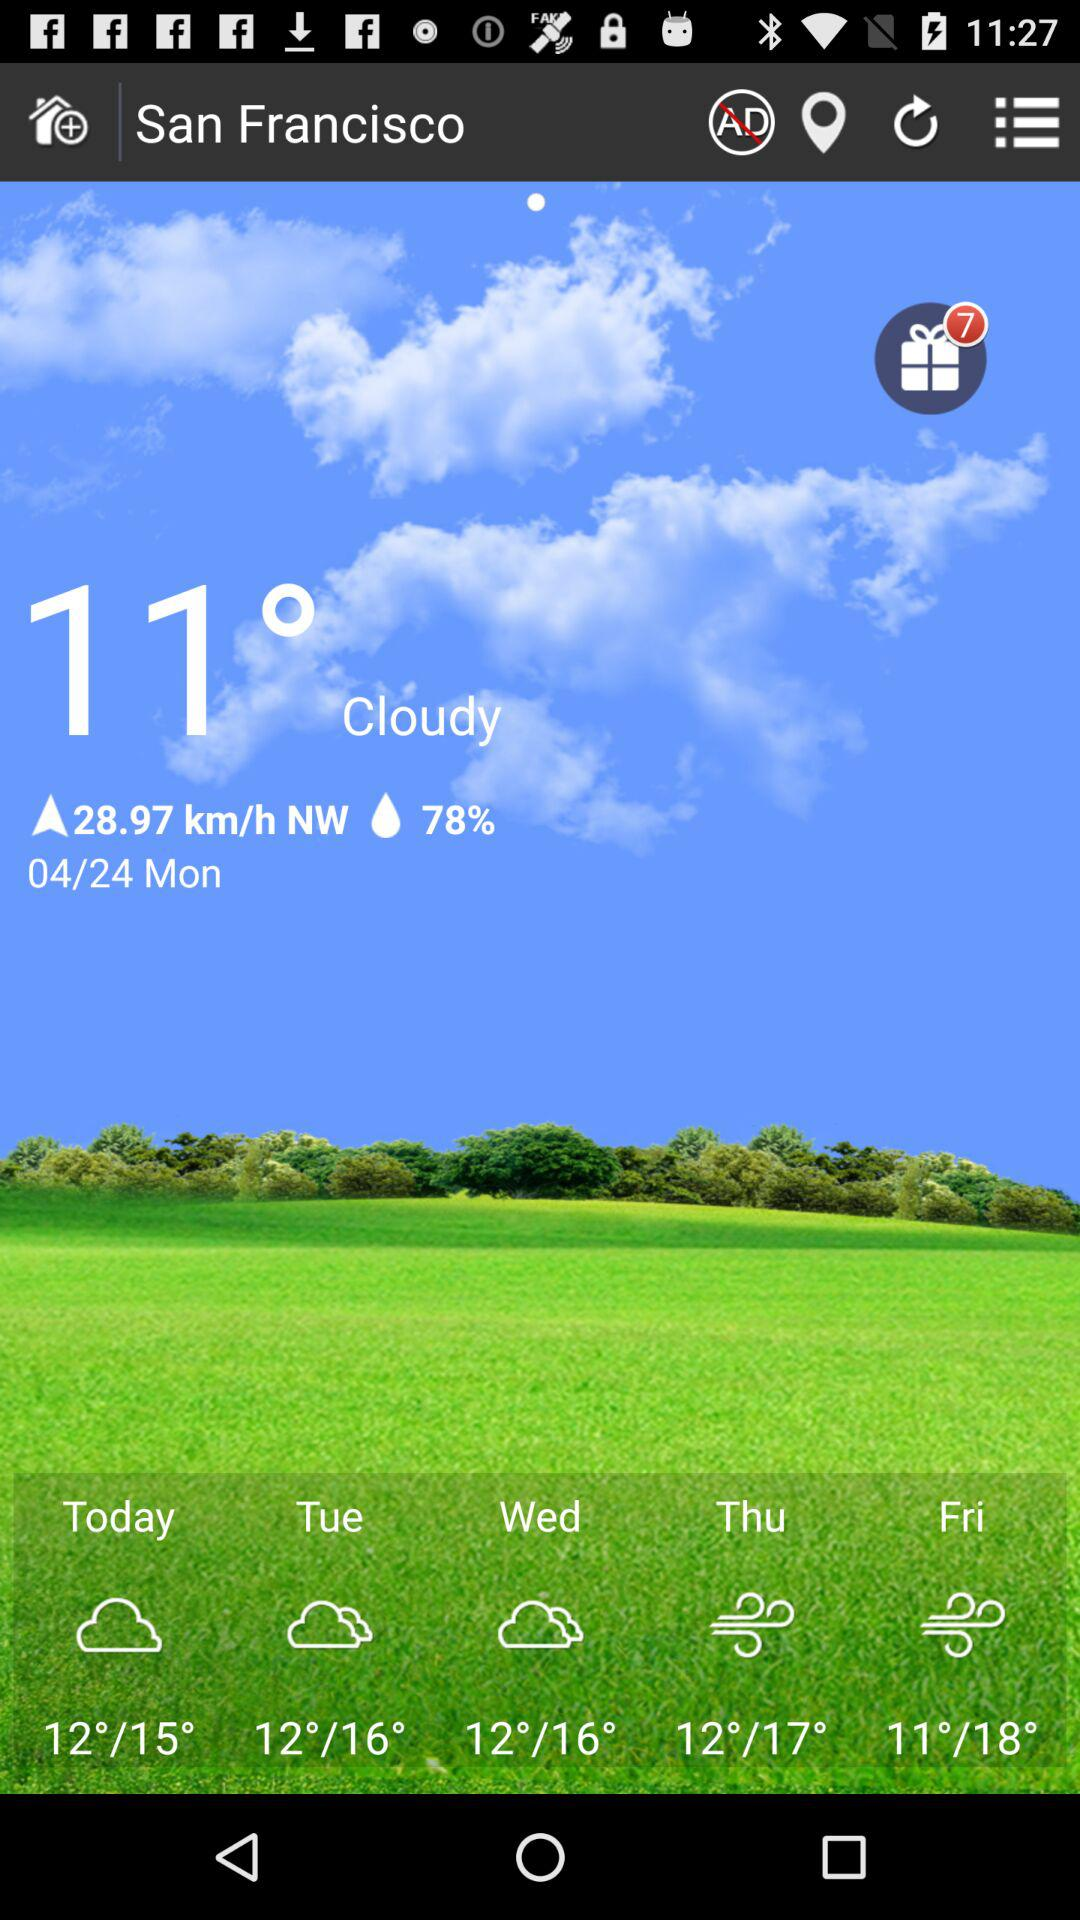What version of the application is this? The version is 2.4. 